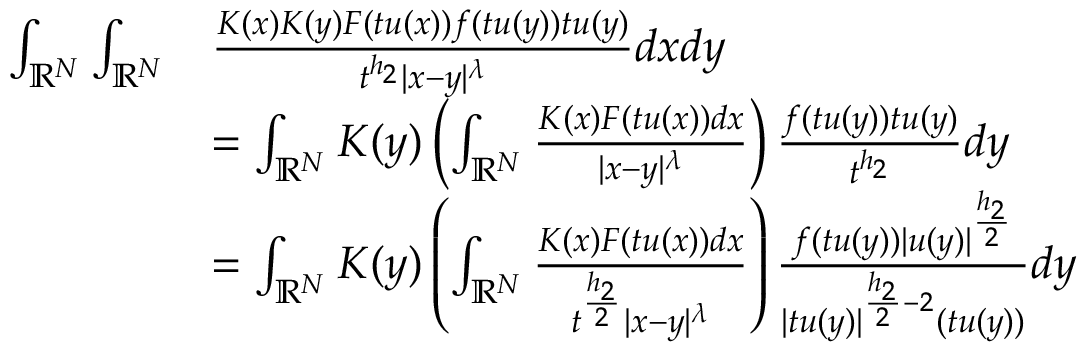<formula> <loc_0><loc_0><loc_500><loc_500>\begin{array} { r l } { \int _ { { \mathbb { R } } ^ { N } } \int _ { { \mathbb { R } } ^ { N } } } & { \frac { K ( x ) K ( y ) F ( t u ( x ) ) f ( t u ( y ) ) t u ( y ) } { t ^ { h _ { 2 } } | x - y | ^ { \lambda } } d x d y } \\ & { = \int _ { { \mathbb { R } } ^ { N } } K ( y ) \left ( \int _ { { \mathbb { R } } ^ { N } } \frac { K ( x ) F ( t u ( x ) ) d x } { | x - y | ^ { \lambda } } \right ) \frac { f ( t u ( y ) ) t u ( y ) } { t ^ { h _ { 2 } } } d y } \\ & { = \int _ { { \mathbb { R } } ^ { N } } K ( y ) \left ( \int _ { { \mathbb { R } } ^ { N } } \frac { K ( x ) F ( t u ( x ) ) d x } { t ^ { \frac { h _ { 2 } } { 2 } } | x - y | ^ { \lambda } } \right ) \frac { f ( t u ( y ) ) | u ( y ) | ^ { \frac { h _ { 2 } } { 2 } } } { | t u ( y ) | ^ { \frac { h _ { 2 } } { 2 } - 2 } ( t u ( y ) ) } d y } \end{array}</formula> 